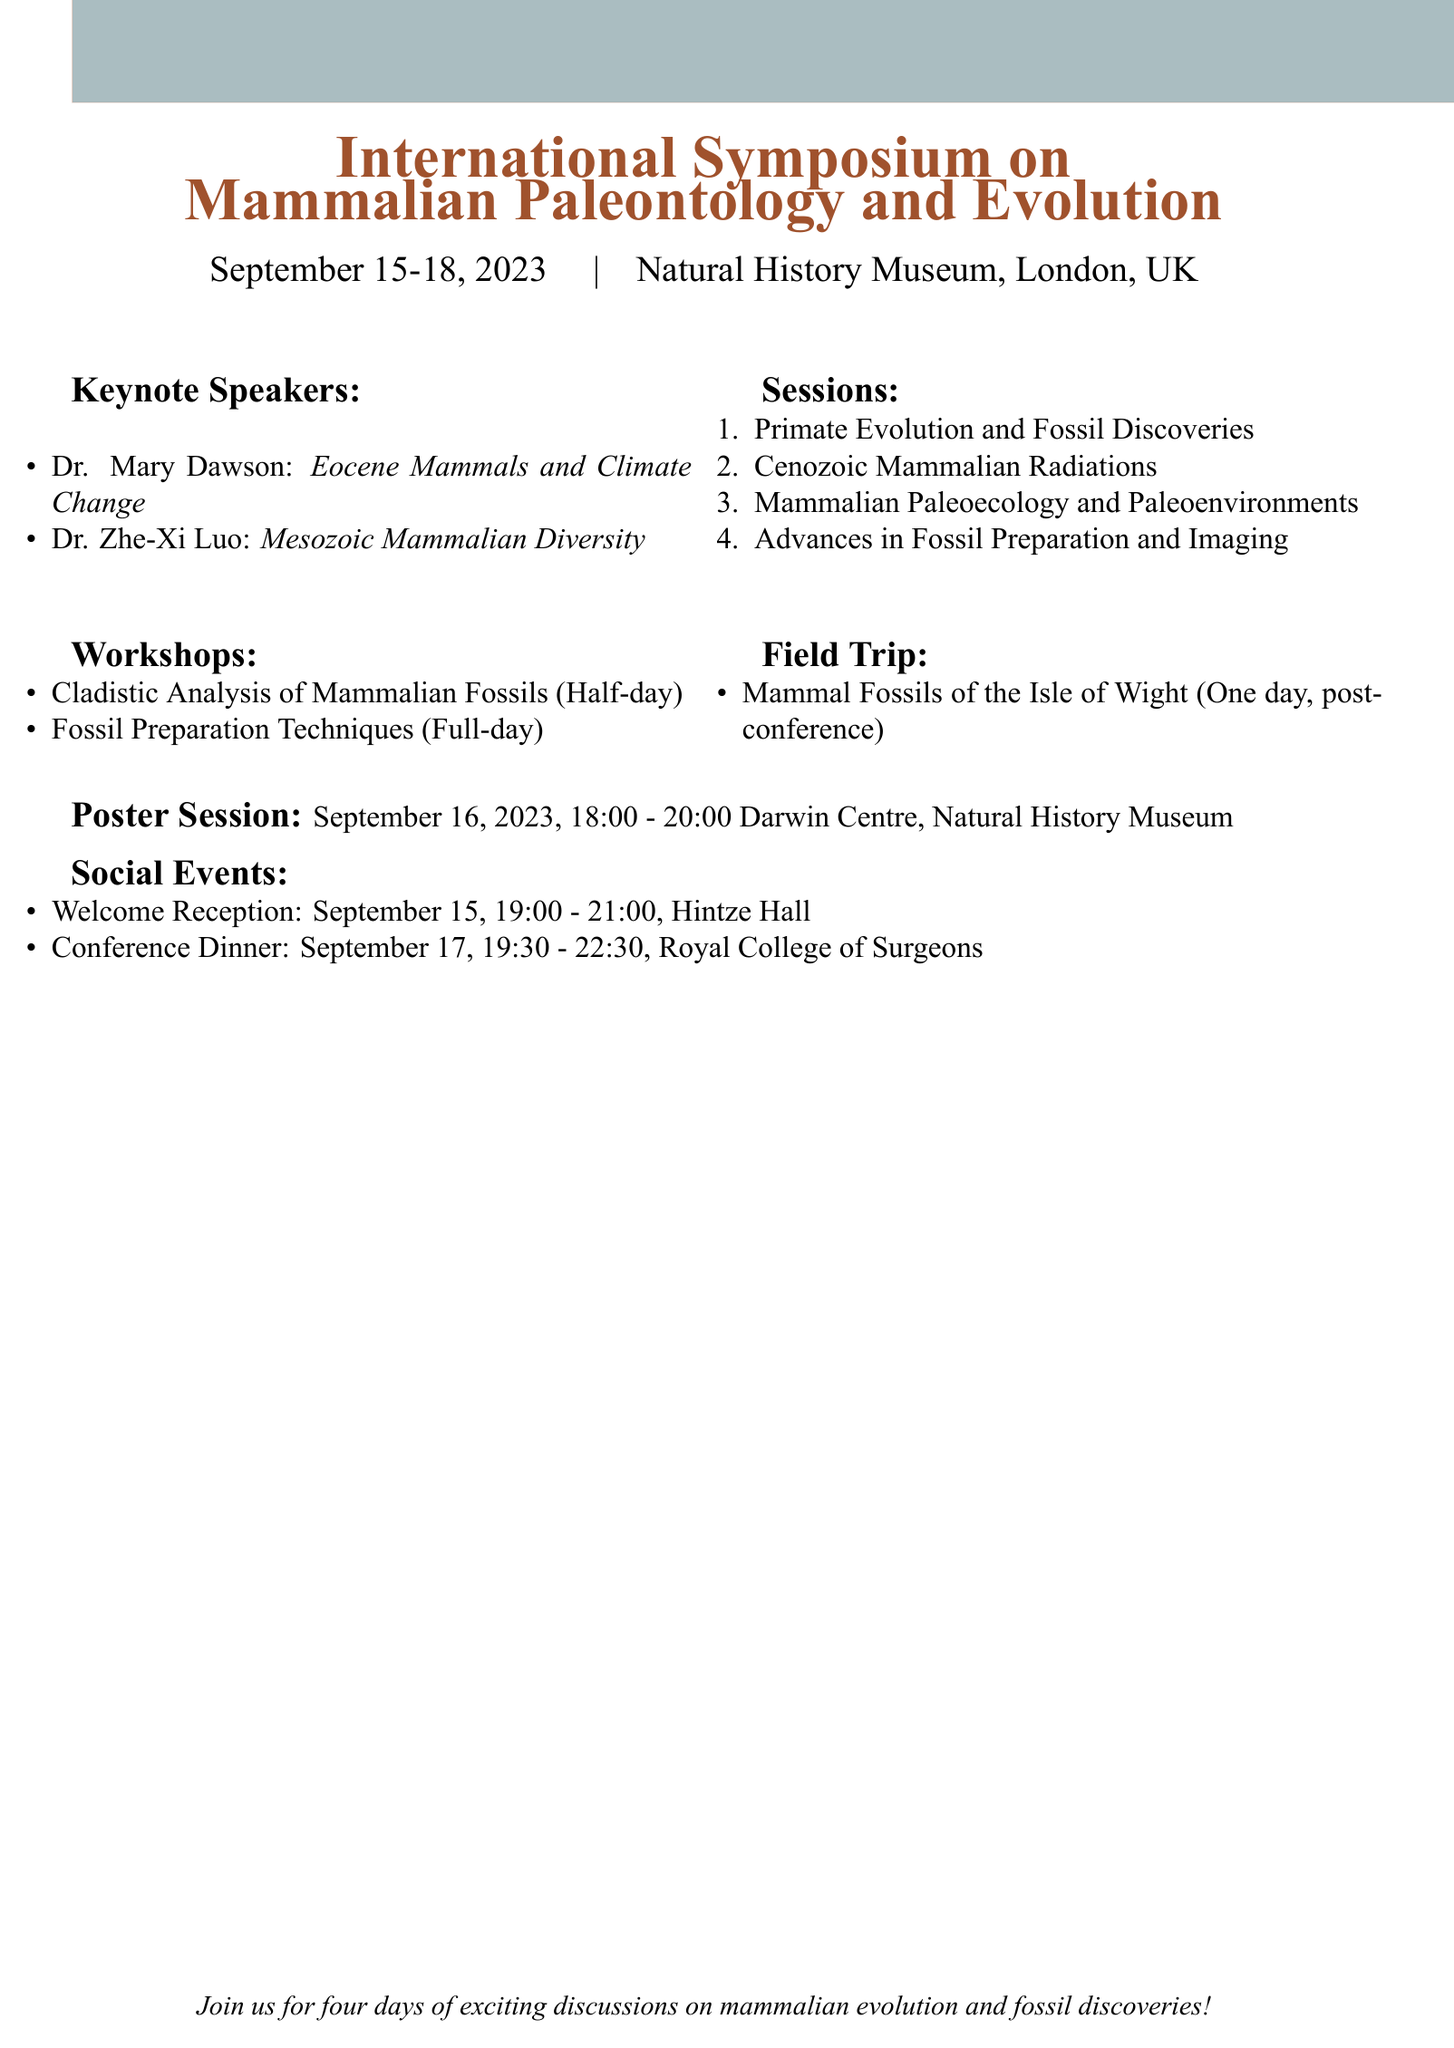What are the dates of the conference? The dates for the conference are mentioned at the beginning, which shows when the event will take place.
Answer: September 15-18, 2023 Who is the chair for the session on Cenozoic Mammalian Radiations? The chairperson for each session is listed in the document, particularly in the session sections.
Answer: Dr. Christine Janis What is the topic of the keynote talk by Dr. Mary Dawson? The topics of each keynote speaker's presentations are included in their respective sections.
Answer: Eocene Mammals and Climate Change: New Insights from the Fossil Record How many sessions are listed in the agenda? The document contains a section listing all the sessions, which can be counted for this information.
Answer: Four What is the duration of the workshop on Fossil Preparation Techniques? The duration of each workshop is specified next to its name in the workshops section.
Answer: Full-day Where will the Welcome Reception be held? The location for each social event is detailed in the document, specifically for the Welcome Reception.
Answer: Hintze Hall, Natural History Museum What field trip is scheduled for post-conference? The field trips are explicitly mentioned in their own section, providing details about the scheduled trip.
Answer: Mammal Fossils of the Isle of Wight How many keynote speakers are there? This can be identified by counting the keynote speakers listed in the respective section of the document.
Answer: Two 